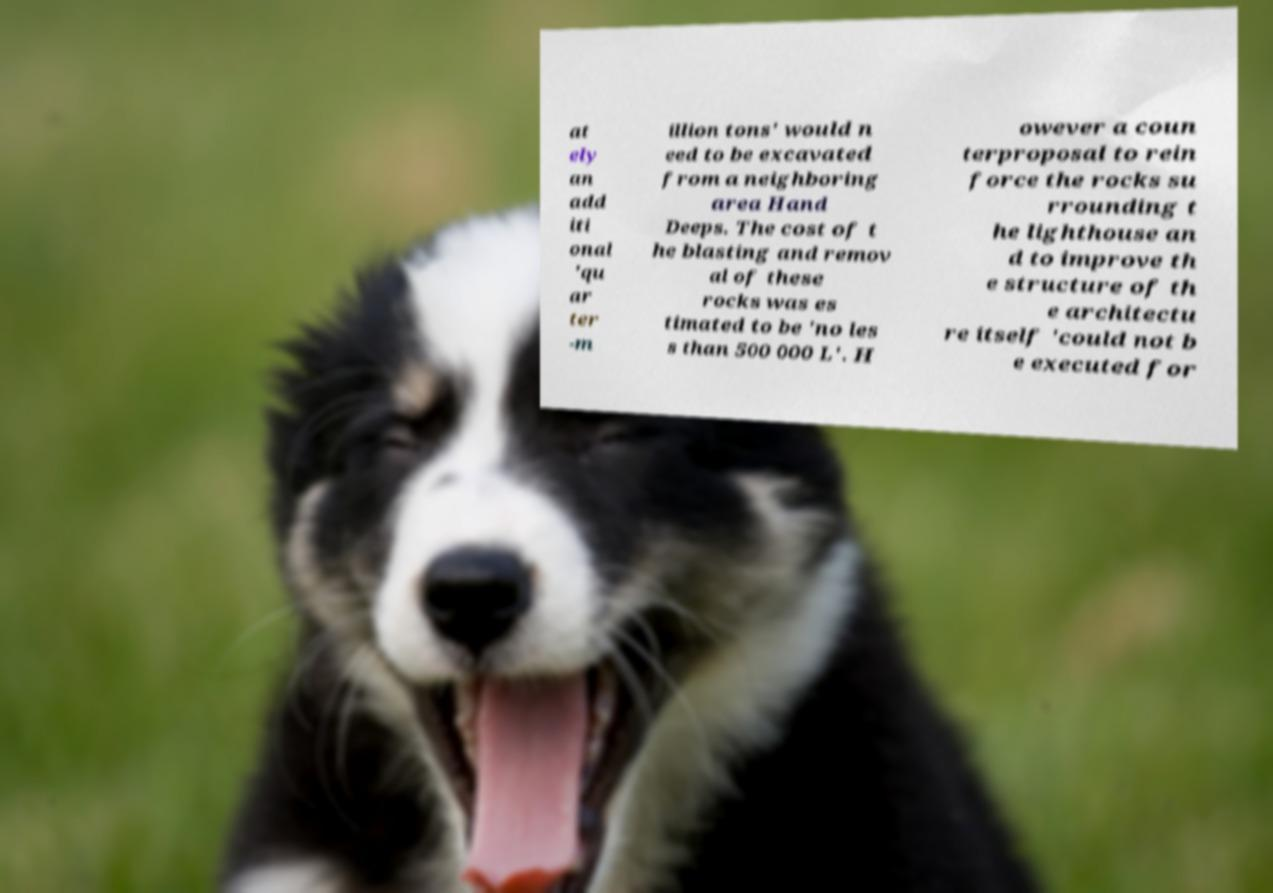Could you extract and type out the text from this image? at ely an add iti onal 'qu ar ter -m illion tons' would n eed to be excavated from a neighboring area Hand Deeps. The cost of t he blasting and remov al of these rocks was es timated to be 'no les s than 500 000 L'. H owever a coun terproposal to rein force the rocks su rrounding t he lighthouse an d to improve th e structure of th e architectu re itself 'could not b e executed for 